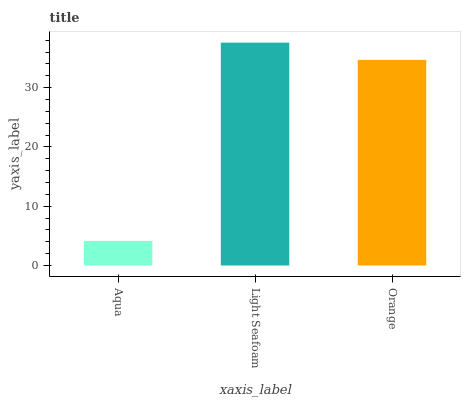Is Orange the minimum?
Answer yes or no. No. Is Orange the maximum?
Answer yes or no. No. Is Light Seafoam greater than Orange?
Answer yes or no. Yes. Is Orange less than Light Seafoam?
Answer yes or no. Yes. Is Orange greater than Light Seafoam?
Answer yes or no. No. Is Light Seafoam less than Orange?
Answer yes or no. No. Is Orange the high median?
Answer yes or no. Yes. Is Orange the low median?
Answer yes or no. Yes. Is Light Seafoam the high median?
Answer yes or no. No. Is Aqua the low median?
Answer yes or no. No. 